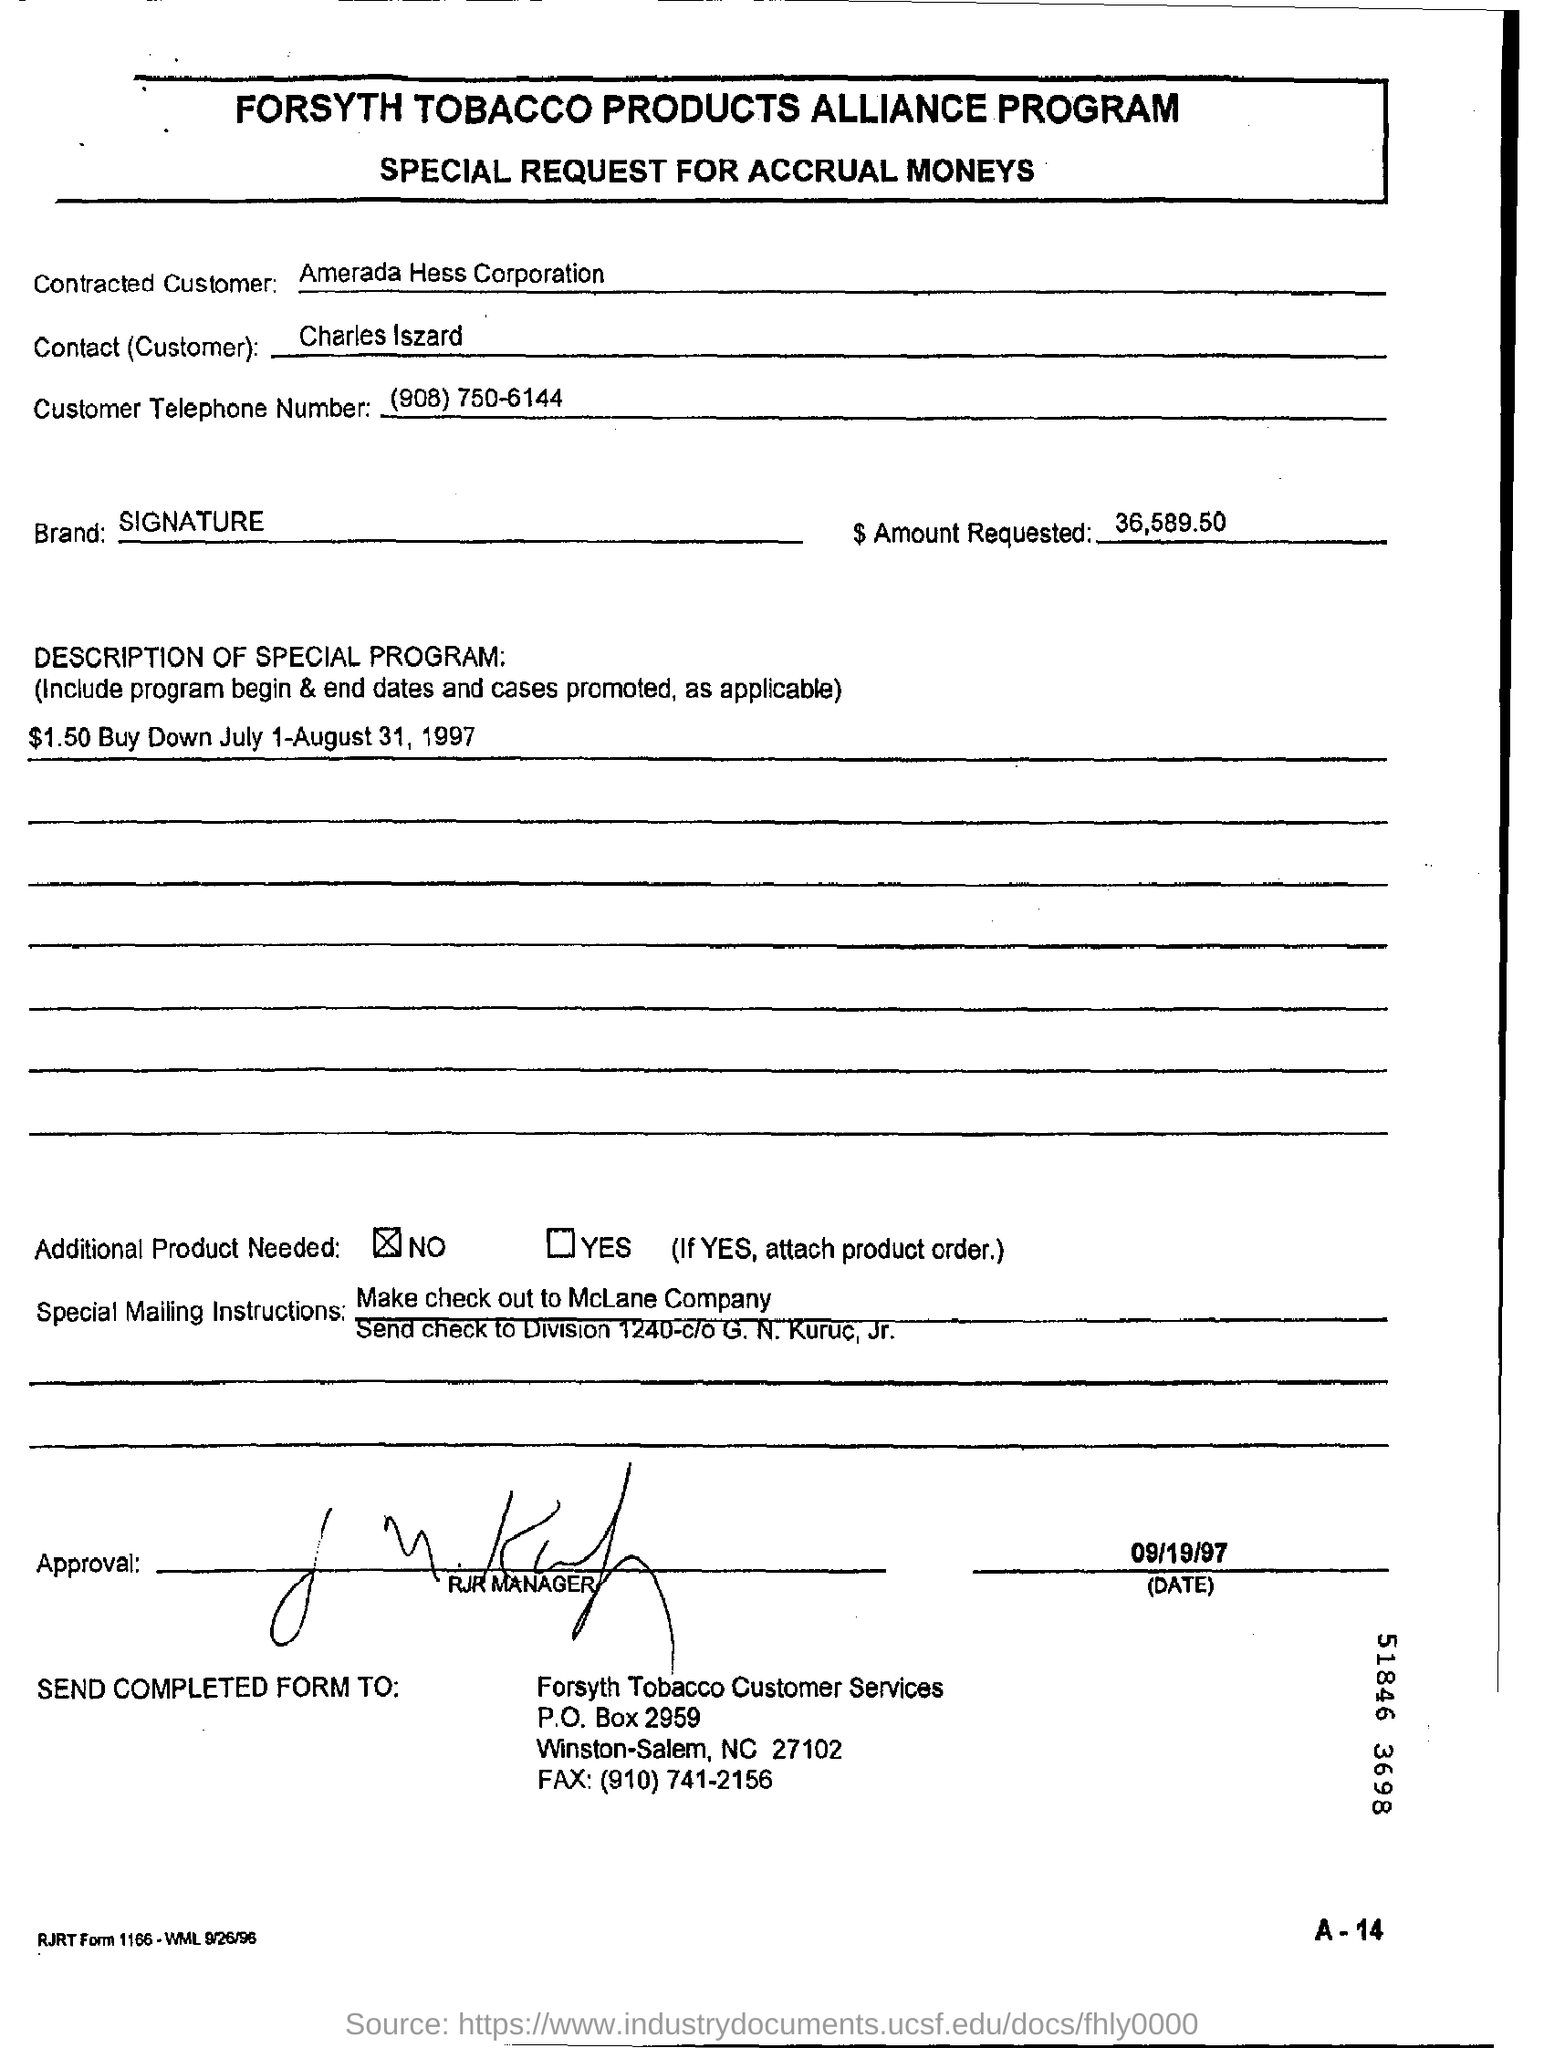Give some essential details in this illustration. What is the brand mentioned in the document? Signature.. The customer's telephone number is 908-750-6144. What is the date of approval? It is September 19, 1997. The approval was given by the RJR Manager. The amount requested is 36,589.50. 